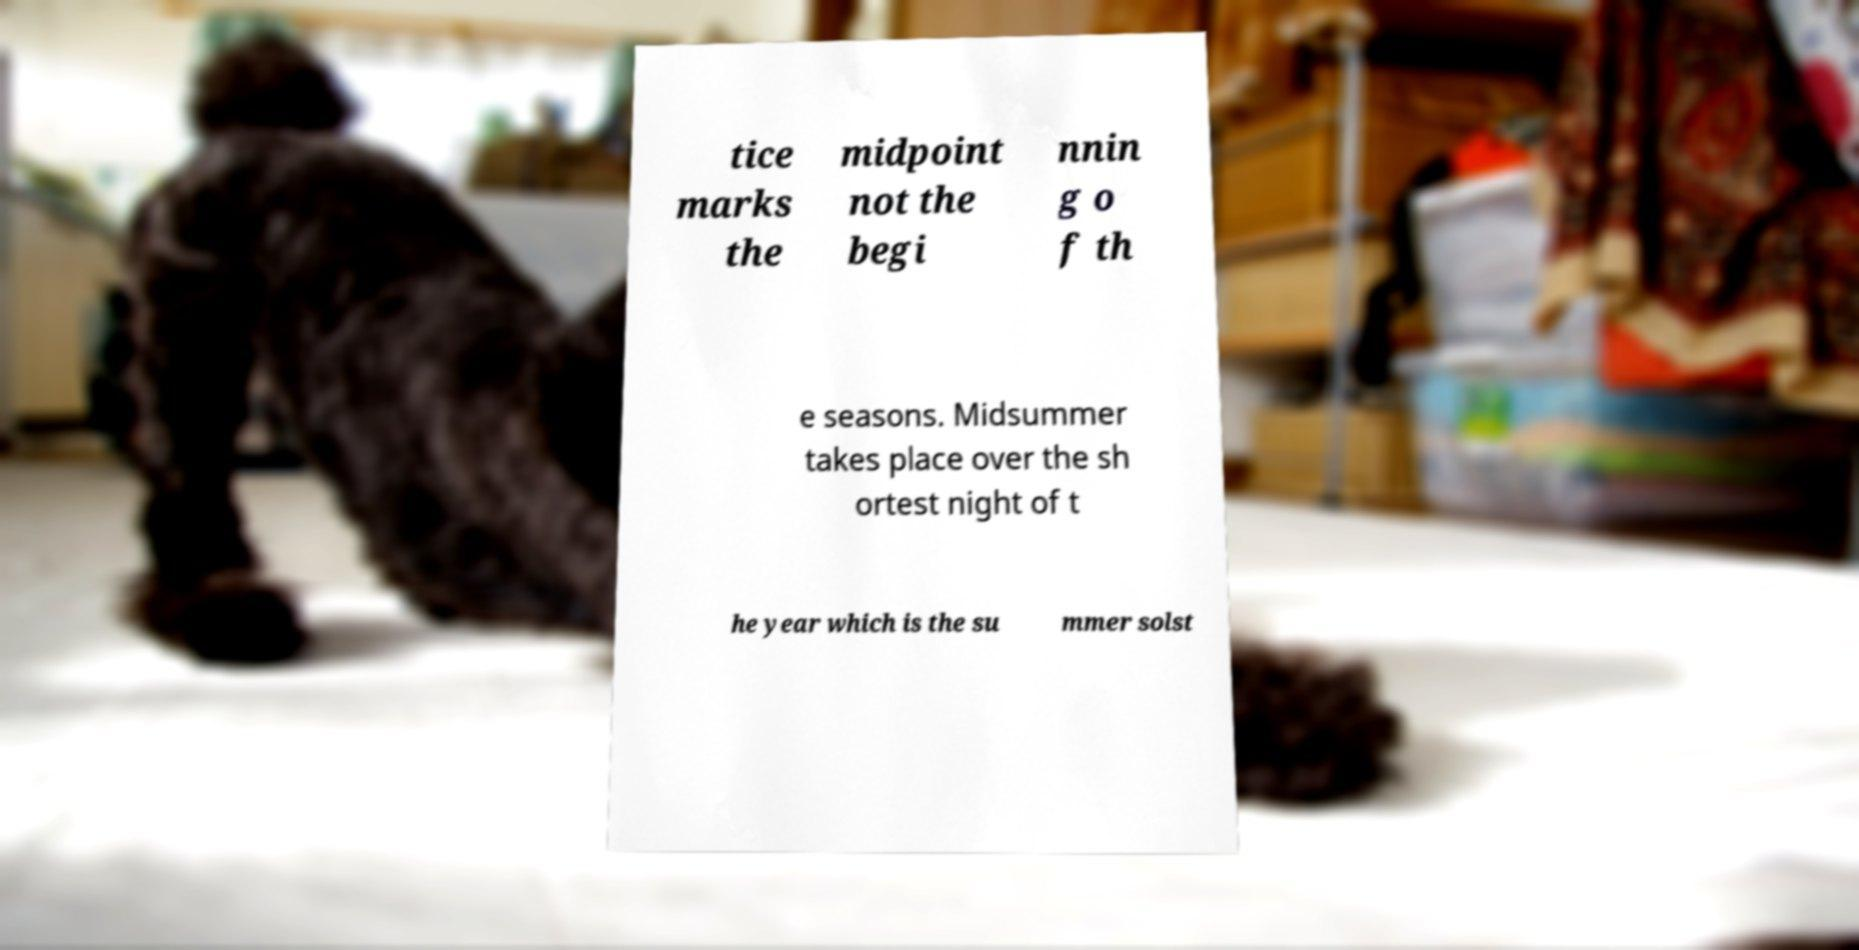Could you extract and type out the text from this image? tice marks the midpoint not the begi nnin g o f th e seasons. Midsummer takes place over the sh ortest night of t he year which is the su mmer solst 